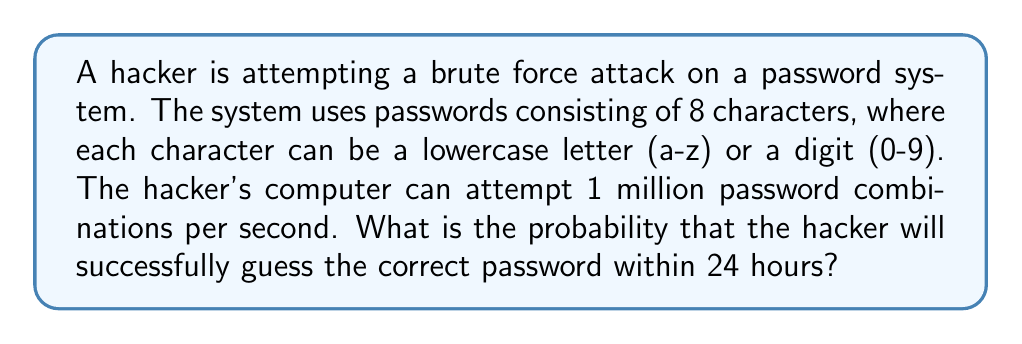Teach me how to tackle this problem. To solve this problem, we need to follow these steps:

1. Calculate the total number of possible password combinations:
   - Number of characters per position: 26 (lowercase letters) + 10 (digits) = 36
   - Number of positions: 8
   - Total combinations: $36^8$

2. Calculate the number of password attempts in 24 hours:
   - Attempts per second: 1,000,000
   - Seconds in 24 hours: 24 * 60 * 60 = 86,400
   - Total attempts: 1,000,000 * 86,400

3. Calculate the probability of success:
   - Probability = (Number of attempts) / (Total possible combinations)

Let's perform the calculations:

1. Total possible combinations:
   $$36^8 = 2,821,109,907,456$$

2. Number of attempts in 24 hours:
   $$1,000,000 * 86,400 = 86,400,000,000$$

3. Probability of success:
   $$P(\text{success}) = \frac{86,400,000,000}{2,821,109,907,456}$$
   
   $$P(\text{success}) \approx 0.0306$$

Therefore, the probability of successfully guessing the correct password within 24 hours is approximately 0.0306 or 3.06%.
Answer: The probability of a successful brute force attack within 24 hours is approximately 0.0306 or 3.06%. 